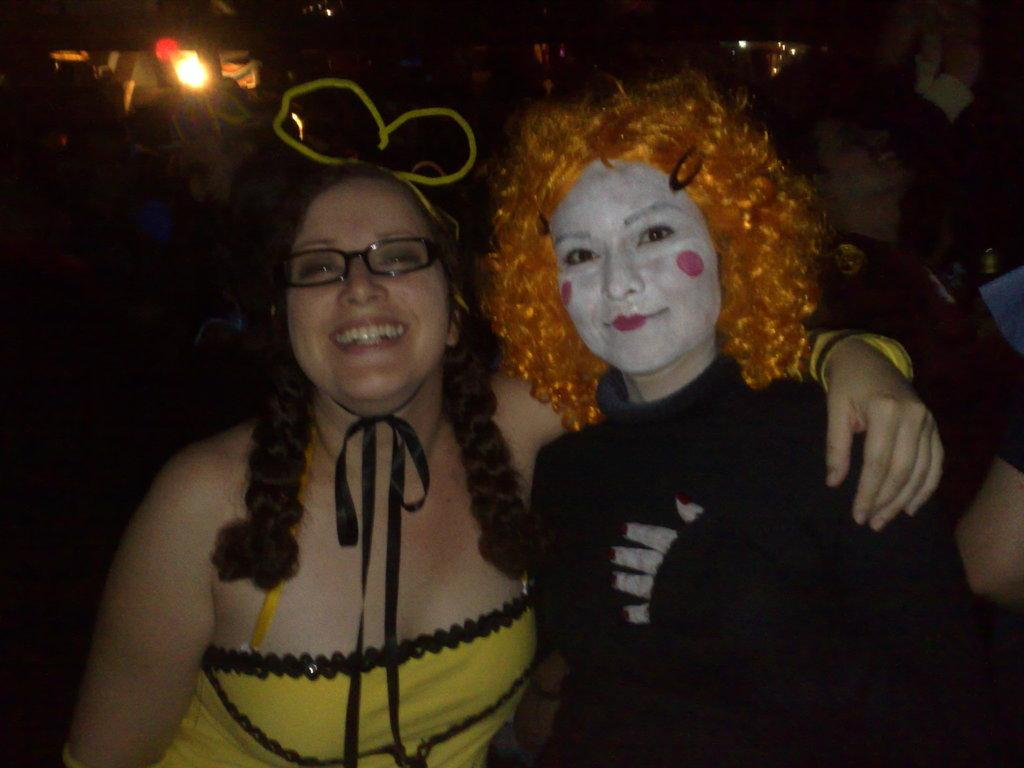How many people are in the image? There are two girls in the image. What are the girls doing in the image? The girls are standing in the image. What is the facial expression of the girls? The girls are smiling in the image. What is the plot of the story involving the doll in the image? There is no doll present in the image, so there is no story or plot involving a doll. 